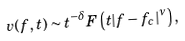Convert formula to latex. <formula><loc_0><loc_0><loc_500><loc_500>v ( f , t ) \sim t ^ { - \delta } F \left ( t | f - f _ { c } | ^ { \nu } \right ) ,</formula> 